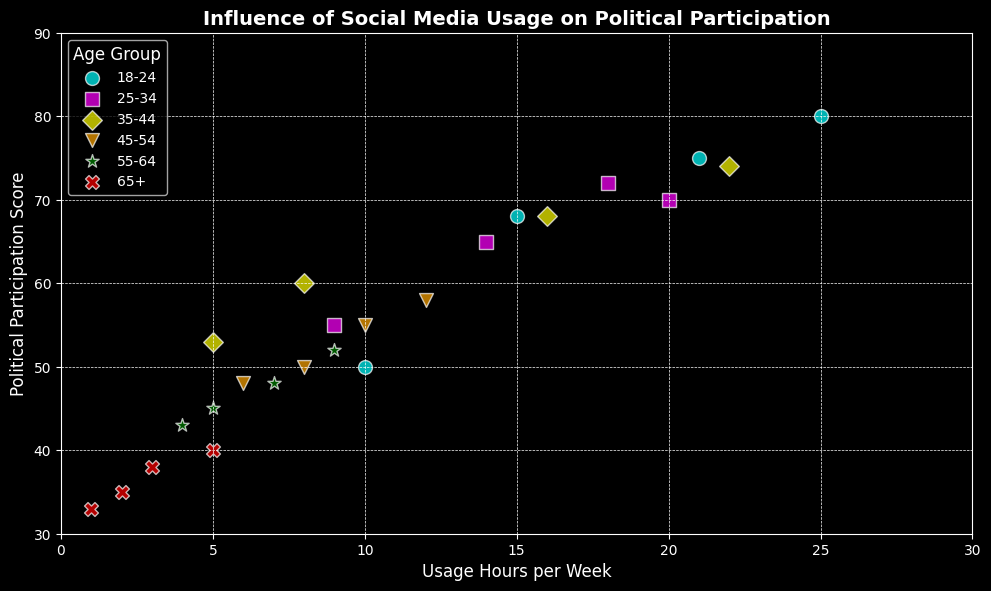Which age group has the highest political participation score? The plot shows political participation scores on the y-axis and age groups identified by different colors and markers. By examining the highest points, the '18-24' age group has the highest score of 80.
Answer: 18-24 How do the political participation scores differ between the '25-34' and '55-64' age groups? The political participation scores for the '25-34' age group range from 55 to 72, whereas the '55-64' age group ranges from 43 to 52. The '25-34' group has generally higher scores.
Answer: 25-34 has higher scores What is the range of social media usage hours per week for the '45-54' age group? Looking at the x-axis values for the '45-54' age group, the usage hours range from 6 to 12 hours per week.
Answer: 6 to 12 hours Which age group shows the most overlap in political participation scores with the '35-44' age group? The '35-44' age group's scores range from 53 to 74. The '25-34' age group, with scores from 55 to 72, shows the most overlap.
Answer: 25-34 Among the age groups shown, which has the lowest average political participation score? The '65+' age group has scores ranging from 33 to 40. Other groups have higher minimum scores. Hence, '65+' has the lowest average participation score.
Answer: 65+ Which age group tends to use social media the most per week? The '18-24' age group shows the highest usage hours per week, up to 25 hours.
Answer: 18-24 If you observe the scatter plot, who has a higher political participation score with similar usage hours: '55-64' or '65+' age group? Looking at similar usage hours (e.g., 5 hours), the '55-64' group has a higher score (52) than the '65+' group (40).
Answer: 55-64 Do any age groups have identical visual markers on the scatter plot? Each age group has a unique marker. There are no identical markers among age groups.
Answer: No 